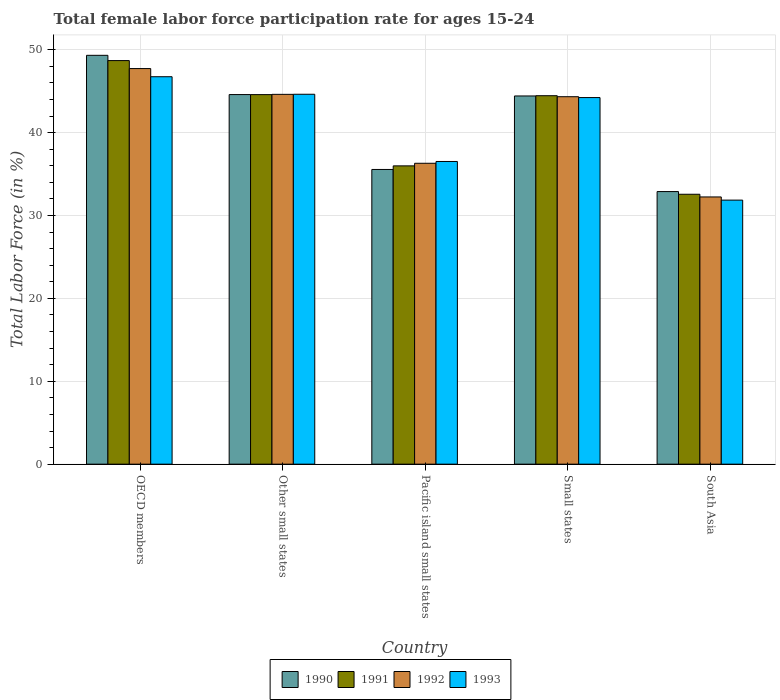Are the number of bars per tick equal to the number of legend labels?
Make the answer very short. Yes. Are the number of bars on each tick of the X-axis equal?
Provide a succinct answer. Yes. How many bars are there on the 5th tick from the left?
Make the answer very short. 4. What is the label of the 1st group of bars from the left?
Your answer should be compact. OECD members. What is the female labor force participation rate in 1991 in Pacific island small states?
Provide a succinct answer. 35.99. Across all countries, what is the maximum female labor force participation rate in 1993?
Provide a short and direct response. 46.75. Across all countries, what is the minimum female labor force participation rate in 1993?
Your answer should be very brief. 31.86. In which country was the female labor force participation rate in 1992 minimum?
Give a very brief answer. South Asia. What is the total female labor force participation rate in 1992 in the graph?
Give a very brief answer. 205.25. What is the difference between the female labor force participation rate in 1993 in OECD members and that in Small states?
Your answer should be compact. 2.52. What is the difference between the female labor force participation rate in 1993 in OECD members and the female labor force participation rate in 1991 in Other small states?
Ensure brevity in your answer.  2.16. What is the average female labor force participation rate in 1990 per country?
Provide a succinct answer. 41.36. What is the difference between the female labor force participation rate of/in 1993 and female labor force participation rate of/in 1992 in OECD members?
Your response must be concise. -0.98. In how many countries, is the female labor force participation rate in 1991 greater than 38 %?
Keep it short and to the point. 3. What is the ratio of the female labor force participation rate in 1991 in Other small states to that in Small states?
Your answer should be very brief. 1. Is the female labor force participation rate in 1990 in OECD members less than that in South Asia?
Offer a terse response. No. What is the difference between the highest and the second highest female labor force participation rate in 1992?
Offer a terse response. 0.28. What is the difference between the highest and the lowest female labor force participation rate in 1992?
Provide a short and direct response. 15.49. Is the sum of the female labor force participation rate in 1992 in Other small states and South Asia greater than the maximum female labor force participation rate in 1993 across all countries?
Provide a succinct answer. Yes. What does the 1st bar from the left in Pacific island small states represents?
Provide a succinct answer. 1990. How many countries are there in the graph?
Your response must be concise. 5. What is the difference between two consecutive major ticks on the Y-axis?
Provide a succinct answer. 10. Does the graph contain any zero values?
Offer a terse response. No. Does the graph contain grids?
Keep it short and to the point. Yes. Where does the legend appear in the graph?
Your answer should be compact. Bottom center. What is the title of the graph?
Your answer should be compact. Total female labor force participation rate for ages 15-24. Does "2011" appear as one of the legend labels in the graph?
Provide a short and direct response. No. What is the label or title of the X-axis?
Your answer should be very brief. Country. What is the Total Labor Force (in %) in 1990 in OECD members?
Offer a terse response. 49.33. What is the Total Labor Force (in %) in 1991 in OECD members?
Offer a terse response. 48.7. What is the Total Labor Force (in %) in 1992 in OECD members?
Your answer should be very brief. 47.73. What is the Total Labor Force (in %) in 1993 in OECD members?
Your response must be concise. 46.75. What is the Total Labor Force (in %) of 1990 in Other small states?
Provide a short and direct response. 44.6. What is the Total Labor Force (in %) of 1991 in Other small states?
Your answer should be compact. 44.59. What is the Total Labor Force (in %) of 1992 in Other small states?
Provide a short and direct response. 44.62. What is the Total Labor Force (in %) in 1993 in Other small states?
Keep it short and to the point. 44.63. What is the Total Labor Force (in %) of 1990 in Pacific island small states?
Ensure brevity in your answer.  35.56. What is the Total Labor Force (in %) in 1991 in Pacific island small states?
Provide a succinct answer. 35.99. What is the Total Labor Force (in %) in 1992 in Pacific island small states?
Your answer should be compact. 36.31. What is the Total Labor Force (in %) in 1993 in Pacific island small states?
Your answer should be very brief. 36.52. What is the Total Labor Force (in %) of 1990 in Small states?
Your answer should be compact. 44.43. What is the Total Labor Force (in %) in 1991 in Small states?
Ensure brevity in your answer.  44.46. What is the Total Labor Force (in %) of 1992 in Small states?
Provide a short and direct response. 44.34. What is the Total Labor Force (in %) of 1993 in Small states?
Your answer should be compact. 44.24. What is the Total Labor Force (in %) of 1990 in South Asia?
Keep it short and to the point. 32.89. What is the Total Labor Force (in %) in 1991 in South Asia?
Offer a terse response. 32.57. What is the Total Labor Force (in %) of 1992 in South Asia?
Your answer should be very brief. 32.24. What is the Total Labor Force (in %) in 1993 in South Asia?
Your answer should be compact. 31.86. Across all countries, what is the maximum Total Labor Force (in %) of 1990?
Offer a very short reply. 49.33. Across all countries, what is the maximum Total Labor Force (in %) in 1991?
Provide a succinct answer. 48.7. Across all countries, what is the maximum Total Labor Force (in %) of 1992?
Provide a short and direct response. 47.73. Across all countries, what is the maximum Total Labor Force (in %) in 1993?
Offer a terse response. 46.75. Across all countries, what is the minimum Total Labor Force (in %) in 1990?
Your response must be concise. 32.89. Across all countries, what is the minimum Total Labor Force (in %) in 1991?
Offer a terse response. 32.57. Across all countries, what is the minimum Total Labor Force (in %) of 1992?
Your answer should be very brief. 32.24. Across all countries, what is the minimum Total Labor Force (in %) in 1993?
Make the answer very short. 31.86. What is the total Total Labor Force (in %) of 1990 in the graph?
Ensure brevity in your answer.  206.81. What is the total Total Labor Force (in %) of 1991 in the graph?
Ensure brevity in your answer.  206.31. What is the total Total Labor Force (in %) of 1992 in the graph?
Your answer should be very brief. 205.25. What is the total Total Labor Force (in %) of 1993 in the graph?
Your answer should be compact. 204. What is the difference between the Total Labor Force (in %) of 1990 in OECD members and that in Other small states?
Provide a succinct answer. 4.74. What is the difference between the Total Labor Force (in %) in 1991 in OECD members and that in Other small states?
Make the answer very short. 4.11. What is the difference between the Total Labor Force (in %) of 1992 in OECD members and that in Other small states?
Keep it short and to the point. 3.11. What is the difference between the Total Labor Force (in %) in 1993 in OECD members and that in Other small states?
Offer a very short reply. 2.12. What is the difference between the Total Labor Force (in %) in 1990 in OECD members and that in Pacific island small states?
Keep it short and to the point. 13.77. What is the difference between the Total Labor Force (in %) of 1991 in OECD members and that in Pacific island small states?
Your response must be concise. 12.7. What is the difference between the Total Labor Force (in %) in 1992 in OECD members and that in Pacific island small states?
Offer a very short reply. 11.43. What is the difference between the Total Labor Force (in %) of 1993 in OECD members and that in Pacific island small states?
Offer a terse response. 10.23. What is the difference between the Total Labor Force (in %) in 1990 in OECD members and that in Small states?
Your answer should be compact. 4.9. What is the difference between the Total Labor Force (in %) in 1991 in OECD members and that in Small states?
Make the answer very short. 4.24. What is the difference between the Total Labor Force (in %) in 1992 in OECD members and that in Small states?
Provide a short and direct response. 3.39. What is the difference between the Total Labor Force (in %) in 1993 in OECD members and that in Small states?
Your answer should be compact. 2.52. What is the difference between the Total Labor Force (in %) of 1990 in OECD members and that in South Asia?
Make the answer very short. 16.44. What is the difference between the Total Labor Force (in %) of 1991 in OECD members and that in South Asia?
Provide a succinct answer. 16.13. What is the difference between the Total Labor Force (in %) in 1992 in OECD members and that in South Asia?
Give a very brief answer. 15.49. What is the difference between the Total Labor Force (in %) in 1993 in OECD members and that in South Asia?
Give a very brief answer. 14.89. What is the difference between the Total Labor Force (in %) of 1990 in Other small states and that in Pacific island small states?
Keep it short and to the point. 9.04. What is the difference between the Total Labor Force (in %) in 1991 in Other small states and that in Pacific island small states?
Provide a short and direct response. 8.6. What is the difference between the Total Labor Force (in %) in 1992 in Other small states and that in Pacific island small states?
Keep it short and to the point. 8.32. What is the difference between the Total Labor Force (in %) in 1993 in Other small states and that in Pacific island small states?
Your answer should be compact. 8.11. What is the difference between the Total Labor Force (in %) in 1990 in Other small states and that in Small states?
Provide a succinct answer. 0.17. What is the difference between the Total Labor Force (in %) in 1991 in Other small states and that in Small states?
Make the answer very short. 0.13. What is the difference between the Total Labor Force (in %) in 1992 in Other small states and that in Small states?
Make the answer very short. 0.28. What is the difference between the Total Labor Force (in %) in 1993 in Other small states and that in Small states?
Your answer should be very brief. 0.4. What is the difference between the Total Labor Force (in %) of 1990 in Other small states and that in South Asia?
Keep it short and to the point. 11.7. What is the difference between the Total Labor Force (in %) of 1991 in Other small states and that in South Asia?
Your response must be concise. 12.02. What is the difference between the Total Labor Force (in %) in 1992 in Other small states and that in South Asia?
Your response must be concise. 12.38. What is the difference between the Total Labor Force (in %) in 1993 in Other small states and that in South Asia?
Keep it short and to the point. 12.77. What is the difference between the Total Labor Force (in %) in 1990 in Pacific island small states and that in Small states?
Provide a short and direct response. -8.87. What is the difference between the Total Labor Force (in %) of 1991 in Pacific island small states and that in Small states?
Your response must be concise. -8.47. What is the difference between the Total Labor Force (in %) in 1992 in Pacific island small states and that in Small states?
Keep it short and to the point. -8.03. What is the difference between the Total Labor Force (in %) of 1993 in Pacific island small states and that in Small states?
Make the answer very short. -7.71. What is the difference between the Total Labor Force (in %) of 1990 in Pacific island small states and that in South Asia?
Your response must be concise. 2.67. What is the difference between the Total Labor Force (in %) in 1991 in Pacific island small states and that in South Asia?
Provide a succinct answer. 3.43. What is the difference between the Total Labor Force (in %) of 1992 in Pacific island small states and that in South Asia?
Your answer should be compact. 4.06. What is the difference between the Total Labor Force (in %) of 1993 in Pacific island small states and that in South Asia?
Your answer should be very brief. 4.66. What is the difference between the Total Labor Force (in %) of 1990 in Small states and that in South Asia?
Offer a terse response. 11.54. What is the difference between the Total Labor Force (in %) of 1991 in Small states and that in South Asia?
Offer a terse response. 11.89. What is the difference between the Total Labor Force (in %) of 1992 in Small states and that in South Asia?
Give a very brief answer. 12.1. What is the difference between the Total Labor Force (in %) in 1993 in Small states and that in South Asia?
Offer a terse response. 12.37. What is the difference between the Total Labor Force (in %) of 1990 in OECD members and the Total Labor Force (in %) of 1991 in Other small states?
Your answer should be compact. 4.74. What is the difference between the Total Labor Force (in %) of 1990 in OECD members and the Total Labor Force (in %) of 1992 in Other small states?
Make the answer very short. 4.71. What is the difference between the Total Labor Force (in %) of 1990 in OECD members and the Total Labor Force (in %) of 1993 in Other small states?
Make the answer very short. 4.7. What is the difference between the Total Labor Force (in %) of 1991 in OECD members and the Total Labor Force (in %) of 1992 in Other small states?
Your answer should be very brief. 4.07. What is the difference between the Total Labor Force (in %) in 1991 in OECD members and the Total Labor Force (in %) in 1993 in Other small states?
Your response must be concise. 4.06. What is the difference between the Total Labor Force (in %) of 1992 in OECD members and the Total Labor Force (in %) of 1993 in Other small states?
Your response must be concise. 3.1. What is the difference between the Total Labor Force (in %) in 1990 in OECD members and the Total Labor Force (in %) in 1991 in Pacific island small states?
Keep it short and to the point. 13.34. What is the difference between the Total Labor Force (in %) in 1990 in OECD members and the Total Labor Force (in %) in 1992 in Pacific island small states?
Your answer should be compact. 13.03. What is the difference between the Total Labor Force (in %) of 1990 in OECD members and the Total Labor Force (in %) of 1993 in Pacific island small states?
Offer a very short reply. 12.81. What is the difference between the Total Labor Force (in %) of 1991 in OECD members and the Total Labor Force (in %) of 1992 in Pacific island small states?
Provide a short and direct response. 12.39. What is the difference between the Total Labor Force (in %) in 1991 in OECD members and the Total Labor Force (in %) in 1993 in Pacific island small states?
Ensure brevity in your answer.  12.17. What is the difference between the Total Labor Force (in %) of 1992 in OECD members and the Total Labor Force (in %) of 1993 in Pacific island small states?
Your answer should be very brief. 11.21. What is the difference between the Total Labor Force (in %) in 1990 in OECD members and the Total Labor Force (in %) in 1991 in Small states?
Your answer should be very brief. 4.87. What is the difference between the Total Labor Force (in %) of 1990 in OECD members and the Total Labor Force (in %) of 1992 in Small states?
Your response must be concise. 4.99. What is the difference between the Total Labor Force (in %) in 1990 in OECD members and the Total Labor Force (in %) in 1993 in Small states?
Your answer should be very brief. 5.1. What is the difference between the Total Labor Force (in %) of 1991 in OECD members and the Total Labor Force (in %) of 1992 in Small states?
Provide a succinct answer. 4.36. What is the difference between the Total Labor Force (in %) in 1991 in OECD members and the Total Labor Force (in %) in 1993 in Small states?
Provide a succinct answer. 4.46. What is the difference between the Total Labor Force (in %) of 1992 in OECD members and the Total Labor Force (in %) of 1993 in Small states?
Give a very brief answer. 3.5. What is the difference between the Total Labor Force (in %) in 1990 in OECD members and the Total Labor Force (in %) in 1991 in South Asia?
Keep it short and to the point. 16.77. What is the difference between the Total Labor Force (in %) in 1990 in OECD members and the Total Labor Force (in %) in 1992 in South Asia?
Offer a terse response. 17.09. What is the difference between the Total Labor Force (in %) of 1990 in OECD members and the Total Labor Force (in %) of 1993 in South Asia?
Your response must be concise. 17.47. What is the difference between the Total Labor Force (in %) of 1991 in OECD members and the Total Labor Force (in %) of 1992 in South Asia?
Provide a succinct answer. 16.45. What is the difference between the Total Labor Force (in %) in 1991 in OECD members and the Total Labor Force (in %) in 1993 in South Asia?
Give a very brief answer. 16.84. What is the difference between the Total Labor Force (in %) in 1992 in OECD members and the Total Labor Force (in %) in 1993 in South Asia?
Offer a terse response. 15.87. What is the difference between the Total Labor Force (in %) of 1990 in Other small states and the Total Labor Force (in %) of 1991 in Pacific island small states?
Make the answer very short. 8.6. What is the difference between the Total Labor Force (in %) in 1990 in Other small states and the Total Labor Force (in %) in 1992 in Pacific island small states?
Give a very brief answer. 8.29. What is the difference between the Total Labor Force (in %) in 1990 in Other small states and the Total Labor Force (in %) in 1993 in Pacific island small states?
Offer a terse response. 8.07. What is the difference between the Total Labor Force (in %) in 1991 in Other small states and the Total Labor Force (in %) in 1992 in Pacific island small states?
Ensure brevity in your answer.  8.28. What is the difference between the Total Labor Force (in %) of 1991 in Other small states and the Total Labor Force (in %) of 1993 in Pacific island small states?
Your answer should be very brief. 8.07. What is the difference between the Total Labor Force (in %) of 1992 in Other small states and the Total Labor Force (in %) of 1993 in Pacific island small states?
Your answer should be compact. 8.1. What is the difference between the Total Labor Force (in %) of 1990 in Other small states and the Total Labor Force (in %) of 1991 in Small states?
Provide a short and direct response. 0.14. What is the difference between the Total Labor Force (in %) of 1990 in Other small states and the Total Labor Force (in %) of 1992 in Small states?
Offer a terse response. 0.26. What is the difference between the Total Labor Force (in %) in 1990 in Other small states and the Total Labor Force (in %) in 1993 in Small states?
Ensure brevity in your answer.  0.36. What is the difference between the Total Labor Force (in %) in 1991 in Other small states and the Total Labor Force (in %) in 1992 in Small states?
Your response must be concise. 0.25. What is the difference between the Total Labor Force (in %) of 1991 in Other small states and the Total Labor Force (in %) of 1993 in Small states?
Your response must be concise. 0.36. What is the difference between the Total Labor Force (in %) of 1992 in Other small states and the Total Labor Force (in %) of 1993 in Small states?
Your answer should be very brief. 0.39. What is the difference between the Total Labor Force (in %) in 1990 in Other small states and the Total Labor Force (in %) in 1991 in South Asia?
Provide a succinct answer. 12.03. What is the difference between the Total Labor Force (in %) in 1990 in Other small states and the Total Labor Force (in %) in 1992 in South Asia?
Your response must be concise. 12.35. What is the difference between the Total Labor Force (in %) of 1990 in Other small states and the Total Labor Force (in %) of 1993 in South Asia?
Keep it short and to the point. 12.74. What is the difference between the Total Labor Force (in %) of 1991 in Other small states and the Total Labor Force (in %) of 1992 in South Asia?
Provide a short and direct response. 12.35. What is the difference between the Total Labor Force (in %) of 1991 in Other small states and the Total Labor Force (in %) of 1993 in South Asia?
Your answer should be very brief. 12.73. What is the difference between the Total Labor Force (in %) in 1992 in Other small states and the Total Labor Force (in %) in 1993 in South Asia?
Offer a terse response. 12.76. What is the difference between the Total Labor Force (in %) of 1990 in Pacific island small states and the Total Labor Force (in %) of 1991 in Small states?
Provide a short and direct response. -8.9. What is the difference between the Total Labor Force (in %) of 1990 in Pacific island small states and the Total Labor Force (in %) of 1992 in Small states?
Provide a succinct answer. -8.78. What is the difference between the Total Labor Force (in %) in 1990 in Pacific island small states and the Total Labor Force (in %) in 1993 in Small states?
Offer a very short reply. -8.67. What is the difference between the Total Labor Force (in %) of 1991 in Pacific island small states and the Total Labor Force (in %) of 1992 in Small states?
Give a very brief answer. -8.35. What is the difference between the Total Labor Force (in %) in 1991 in Pacific island small states and the Total Labor Force (in %) in 1993 in Small states?
Your answer should be compact. -8.24. What is the difference between the Total Labor Force (in %) of 1992 in Pacific island small states and the Total Labor Force (in %) of 1993 in Small states?
Offer a terse response. -7.93. What is the difference between the Total Labor Force (in %) of 1990 in Pacific island small states and the Total Labor Force (in %) of 1991 in South Asia?
Offer a very short reply. 2.99. What is the difference between the Total Labor Force (in %) in 1990 in Pacific island small states and the Total Labor Force (in %) in 1992 in South Asia?
Provide a short and direct response. 3.32. What is the difference between the Total Labor Force (in %) of 1990 in Pacific island small states and the Total Labor Force (in %) of 1993 in South Asia?
Offer a terse response. 3.7. What is the difference between the Total Labor Force (in %) in 1991 in Pacific island small states and the Total Labor Force (in %) in 1992 in South Asia?
Give a very brief answer. 3.75. What is the difference between the Total Labor Force (in %) in 1991 in Pacific island small states and the Total Labor Force (in %) in 1993 in South Asia?
Your response must be concise. 4.13. What is the difference between the Total Labor Force (in %) of 1992 in Pacific island small states and the Total Labor Force (in %) of 1993 in South Asia?
Offer a very short reply. 4.45. What is the difference between the Total Labor Force (in %) of 1990 in Small states and the Total Labor Force (in %) of 1991 in South Asia?
Your response must be concise. 11.86. What is the difference between the Total Labor Force (in %) in 1990 in Small states and the Total Labor Force (in %) in 1992 in South Asia?
Your response must be concise. 12.19. What is the difference between the Total Labor Force (in %) of 1990 in Small states and the Total Labor Force (in %) of 1993 in South Asia?
Keep it short and to the point. 12.57. What is the difference between the Total Labor Force (in %) in 1991 in Small states and the Total Labor Force (in %) in 1992 in South Asia?
Ensure brevity in your answer.  12.22. What is the difference between the Total Labor Force (in %) in 1991 in Small states and the Total Labor Force (in %) in 1993 in South Asia?
Your response must be concise. 12.6. What is the difference between the Total Labor Force (in %) of 1992 in Small states and the Total Labor Force (in %) of 1993 in South Asia?
Your answer should be compact. 12.48. What is the average Total Labor Force (in %) of 1990 per country?
Provide a short and direct response. 41.36. What is the average Total Labor Force (in %) of 1991 per country?
Offer a very short reply. 41.26. What is the average Total Labor Force (in %) in 1992 per country?
Make the answer very short. 41.05. What is the average Total Labor Force (in %) of 1993 per country?
Your answer should be very brief. 40.8. What is the difference between the Total Labor Force (in %) of 1990 and Total Labor Force (in %) of 1991 in OECD members?
Your answer should be compact. 0.64. What is the difference between the Total Labor Force (in %) of 1990 and Total Labor Force (in %) of 1992 in OECD members?
Your answer should be compact. 1.6. What is the difference between the Total Labor Force (in %) of 1990 and Total Labor Force (in %) of 1993 in OECD members?
Keep it short and to the point. 2.58. What is the difference between the Total Labor Force (in %) in 1991 and Total Labor Force (in %) in 1992 in OECD members?
Ensure brevity in your answer.  0.96. What is the difference between the Total Labor Force (in %) in 1991 and Total Labor Force (in %) in 1993 in OECD members?
Provide a short and direct response. 1.95. What is the difference between the Total Labor Force (in %) in 1990 and Total Labor Force (in %) in 1991 in Other small states?
Offer a terse response. 0.01. What is the difference between the Total Labor Force (in %) in 1990 and Total Labor Force (in %) in 1992 in Other small states?
Keep it short and to the point. -0.03. What is the difference between the Total Labor Force (in %) in 1990 and Total Labor Force (in %) in 1993 in Other small states?
Offer a terse response. -0.04. What is the difference between the Total Labor Force (in %) of 1991 and Total Labor Force (in %) of 1992 in Other small states?
Offer a terse response. -0.03. What is the difference between the Total Labor Force (in %) in 1991 and Total Labor Force (in %) in 1993 in Other small states?
Offer a terse response. -0.04. What is the difference between the Total Labor Force (in %) of 1992 and Total Labor Force (in %) of 1993 in Other small states?
Make the answer very short. -0.01. What is the difference between the Total Labor Force (in %) of 1990 and Total Labor Force (in %) of 1991 in Pacific island small states?
Offer a terse response. -0.43. What is the difference between the Total Labor Force (in %) of 1990 and Total Labor Force (in %) of 1992 in Pacific island small states?
Ensure brevity in your answer.  -0.75. What is the difference between the Total Labor Force (in %) of 1990 and Total Labor Force (in %) of 1993 in Pacific island small states?
Keep it short and to the point. -0.96. What is the difference between the Total Labor Force (in %) of 1991 and Total Labor Force (in %) of 1992 in Pacific island small states?
Ensure brevity in your answer.  -0.31. What is the difference between the Total Labor Force (in %) of 1991 and Total Labor Force (in %) of 1993 in Pacific island small states?
Give a very brief answer. -0.53. What is the difference between the Total Labor Force (in %) of 1992 and Total Labor Force (in %) of 1993 in Pacific island small states?
Offer a terse response. -0.22. What is the difference between the Total Labor Force (in %) of 1990 and Total Labor Force (in %) of 1991 in Small states?
Your response must be concise. -0.03. What is the difference between the Total Labor Force (in %) of 1990 and Total Labor Force (in %) of 1992 in Small states?
Ensure brevity in your answer.  0.09. What is the difference between the Total Labor Force (in %) of 1990 and Total Labor Force (in %) of 1993 in Small states?
Ensure brevity in your answer.  0.19. What is the difference between the Total Labor Force (in %) in 1991 and Total Labor Force (in %) in 1992 in Small states?
Keep it short and to the point. 0.12. What is the difference between the Total Labor Force (in %) in 1991 and Total Labor Force (in %) in 1993 in Small states?
Provide a succinct answer. 0.22. What is the difference between the Total Labor Force (in %) of 1992 and Total Labor Force (in %) of 1993 in Small states?
Provide a short and direct response. 0.1. What is the difference between the Total Labor Force (in %) of 1990 and Total Labor Force (in %) of 1991 in South Asia?
Your answer should be compact. 0.32. What is the difference between the Total Labor Force (in %) in 1990 and Total Labor Force (in %) in 1992 in South Asia?
Provide a succinct answer. 0.65. What is the difference between the Total Labor Force (in %) of 1990 and Total Labor Force (in %) of 1993 in South Asia?
Your answer should be very brief. 1.03. What is the difference between the Total Labor Force (in %) of 1991 and Total Labor Force (in %) of 1992 in South Asia?
Offer a very short reply. 0.32. What is the difference between the Total Labor Force (in %) in 1991 and Total Labor Force (in %) in 1993 in South Asia?
Provide a short and direct response. 0.71. What is the difference between the Total Labor Force (in %) in 1992 and Total Labor Force (in %) in 1993 in South Asia?
Your answer should be compact. 0.38. What is the ratio of the Total Labor Force (in %) in 1990 in OECD members to that in Other small states?
Provide a succinct answer. 1.11. What is the ratio of the Total Labor Force (in %) of 1991 in OECD members to that in Other small states?
Provide a succinct answer. 1.09. What is the ratio of the Total Labor Force (in %) in 1992 in OECD members to that in Other small states?
Offer a very short reply. 1.07. What is the ratio of the Total Labor Force (in %) of 1993 in OECD members to that in Other small states?
Your answer should be very brief. 1.05. What is the ratio of the Total Labor Force (in %) of 1990 in OECD members to that in Pacific island small states?
Give a very brief answer. 1.39. What is the ratio of the Total Labor Force (in %) in 1991 in OECD members to that in Pacific island small states?
Provide a succinct answer. 1.35. What is the ratio of the Total Labor Force (in %) of 1992 in OECD members to that in Pacific island small states?
Keep it short and to the point. 1.31. What is the ratio of the Total Labor Force (in %) in 1993 in OECD members to that in Pacific island small states?
Provide a short and direct response. 1.28. What is the ratio of the Total Labor Force (in %) in 1990 in OECD members to that in Small states?
Offer a terse response. 1.11. What is the ratio of the Total Labor Force (in %) of 1991 in OECD members to that in Small states?
Keep it short and to the point. 1.1. What is the ratio of the Total Labor Force (in %) in 1992 in OECD members to that in Small states?
Your answer should be compact. 1.08. What is the ratio of the Total Labor Force (in %) in 1993 in OECD members to that in Small states?
Offer a very short reply. 1.06. What is the ratio of the Total Labor Force (in %) of 1990 in OECD members to that in South Asia?
Your response must be concise. 1.5. What is the ratio of the Total Labor Force (in %) of 1991 in OECD members to that in South Asia?
Provide a succinct answer. 1.5. What is the ratio of the Total Labor Force (in %) of 1992 in OECD members to that in South Asia?
Your response must be concise. 1.48. What is the ratio of the Total Labor Force (in %) in 1993 in OECD members to that in South Asia?
Ensure brevity in your answer.  1.47. What is the ratio of the Total Labor Force (in %) in 1990 in Other small states to that in Pacific island small states?
Offer a terse response. 1.25. What is the ratio of the Total Labor Force (in %) in 1991 in Other small states to that in Pacific island small states?
Ensure brevity in your answer.  1.24. What is the ratio of the Total Labor Force (in %) in 1992 in Other small states to that in Pacific island small states?
Your response must be concise. 1.23. What is the ratio of the Total Labor Force (in %) of 1993 in Other small states to that in Pacific island small states?
Your answer should be compact. 1.22. What is the ratio of the Total Labor Force (in %) of 1992 in Other small states to that in Small states?
Provide a short and direct response. 1.01. What is the ratio of the Total Labor Force (in %) of 1993 in Other small states to that in Small states?
Keep it short and to the point. 1.01. What is the ratio of the Total Labor Force (in %) in 1990 in Other small states to that in South Asia?
Make the answer very short. 1.36. What is the ratio of the Total Labor Force (in %) of 1991 in Other small states to that in South Asia?
Keep it short and to the point. 1.37. What is the ratio of the Total Labor Force (in %) in 1992 in Other small states to that in South Asia?
Ensure brevity in your answer.  1.38. What is the ratio of the Total Labor Force (in %) in 1993 in Other small states to that in South Asia?
Ensure brevity in your answer.  1.4. What is the ratio of the Total Labor Force (in %) in 1990 in Pacific island small states to that in Small states?
Your answer should be compact. 0.8. What is the ratio of the Total Labor Force (in %) of 1991 in Pacific island small states to that in Small states?
Your answer should be very brief. 0.81. What is the ratio of the Total Labor Force (in %) in 1992 in Pacific island small states to that in Small states?
Provide a succinct answer. 0.82. What is the ratio of the Total Labor Force (in %) in 1993 in Pacific island small states to that in Small states?
Offer a terse response. 0.83. What is the ratio of the Total Labor Force (in %) in 1990 in Pacific island small states to that in South Asia?
Provide a succinct answer. 1.08. What is the ratio of the Total Labor Force (in %) in 1991 in Pacific island small states to that in South Asia?
Make the answer very short. 1.11. What is the ratio of the Total Labor Force (in %) in 1992 in Pacific island small states to that in South Asia?
Offer a very short reply. 1.13. What is the ratio of the Total Labor Force (in %) in 1993 in Pacific island small states to that in South Asia?
Your response must be concise. 1.15. What is the ratio of the Total Labor Force (in %) of 1990 in Small states to that in South Asia?
Provide a short and direct response. 1.35. What is the ratio of the Total Labor Force (in %) of 1991 in Small states to that in South Asia?
Offer a terse response. 1.37. What is the ratio of the Total Labor Force (in %) in 1992 in Small states to that in South Asia?
Provide a succinct answer. 1.38. What is the ratio of the Total Labor Force (in %) in 1993 in Small states to that in South Asia?
Offer a terse response. 1.39. What is the difference between the highest and the second highest Total Labor Force (in %) of 1990?
Offer a very short reply. 4.74. What is the difference between the highest and the second highest Total Labor Force (in %) of 1991?
Offer a terse response. 4.11. What is the difference between the highest and the second highest Total Labor Force (in %) of 1992?
Your response must be concise. 3.11. What is the difference between the highest and the second highest Total Labor Force (in %) of 1993?
Keep it short and to the point. 2.12. What is the difference between the highest and the lowest Total Labor Force (in %) of 1990?
Provide a succinct answer. 16.44. What is the difference between the highest and the lowest Total Labor Force (in %) in 1991?
Offer a terse response. 16.13. What is the difference between the highest and the lowest Total Labor Force (in %) of 1992?
Provide a succinct answer. 15.49. What is the difference between the highest and the lowest Total Labor Force (in %) of 1993?
Keep it short and to the point. 14.89. 